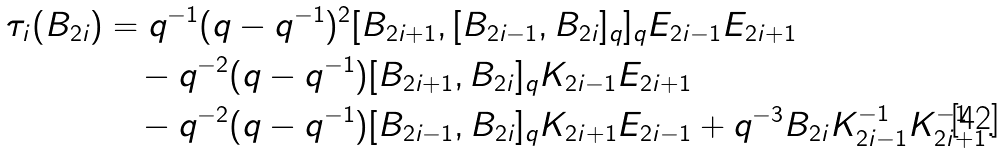<formula> <loc_0><loc_0><loc_500><loc_500>\tau _ { i } ( B _ { 2 i } ) & = q ^ { - 1 } ( q - q ^ { - 1 } ) ^ { 2 } [ B _ { 2 i + 1 } , [ B _ { 2 i - 1 } , B _ { 2 i } ] _ { q } ] _ { q } E _ { 2 i - 1 } E _ { 2 i + 1 } \\ & \quad - q ^ { - 2 } ( q - q ^ { - 1 } ) [ B _ { 2 i + 1 } , B _ { 2 i } ] _ { q } K _ { 2 i - 1 } E _ { 2 i + 1 } \\ & \quad - q ^ { - 2 } ( q - q ^ { - 1 } ) [ B _ { 2 i - 1 } , B _ { 2 i } ] _ { q } K _ { 2 i + 1 } E _ { 2 i - 1 } + q ^ { - 3 } B _ { 2 i } K ^ { - 1 } _ { 2 i - 1 } K ^ { - 1 } _ { 2 i + 1 } .</formula> 